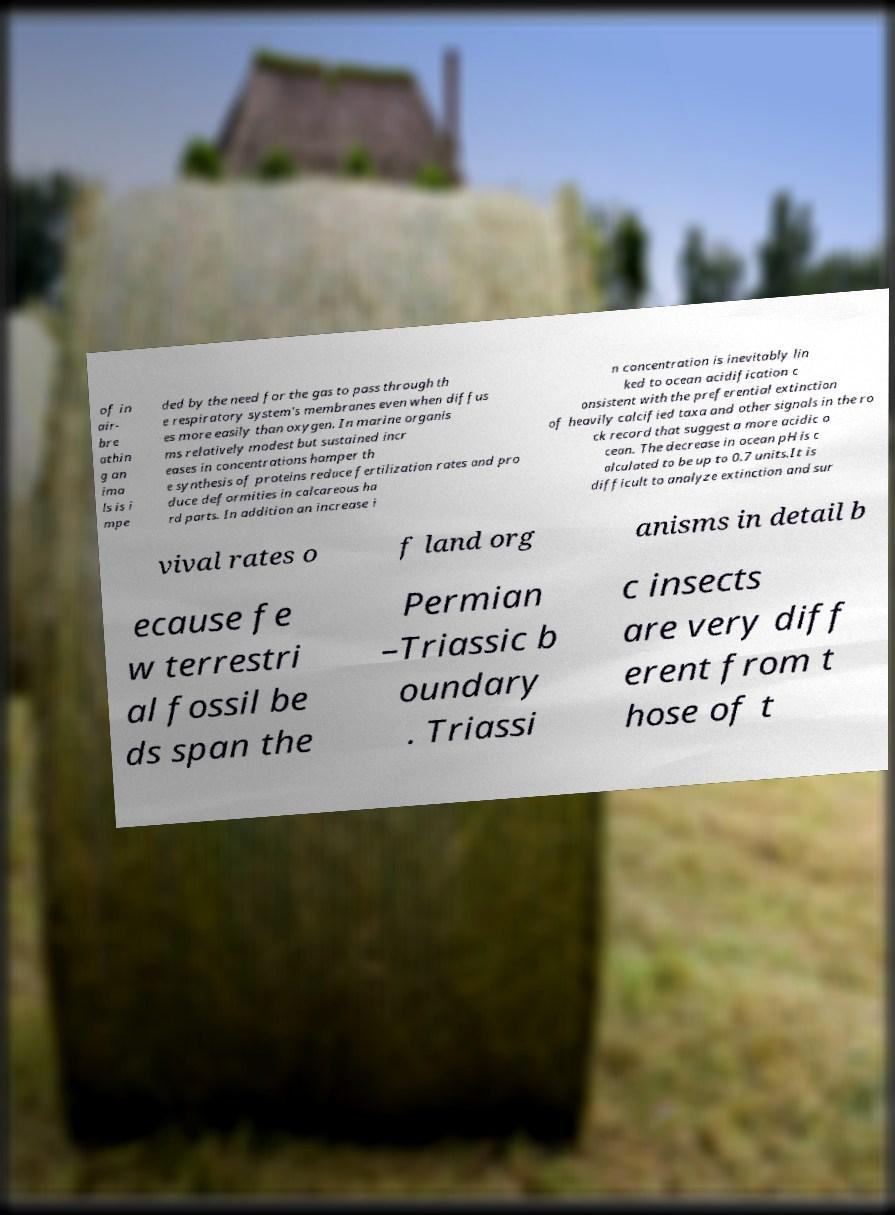Could you assist in decoding the text presented in this image and type it out clearly? of in air- bre athin g an ima ls is i mpe ded by the need for the gas to pass through th e respiratory system's membranes even when diffus es more easily than oxygen. In marine organis ms relatively modest but sustained incr eases in concentrations hamper th e synthesis of proteins reduce fertilization rates and pro duce deformities in calcareous ha rd parts. In addition an increase i n concentration is inevitably lin ked to ocean acidification c onsistent with the preferential extinction of heavily calcified taxa and other signals in the ro ck record that suggest a more acidic o cean. The decrease in ocean pH is c alculated to be up to 0.7 units.It is difficult to analyze extinction and sur vival rates o f land org anisms in detail b ecause fe w terrestri al fossil be ds span the Permian –Triassic b oundary . Triassi c insects are very diff erent from t hose of t 